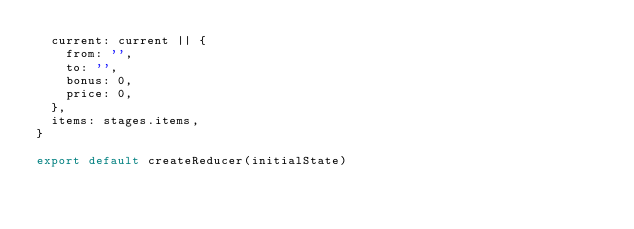Convert code to text. <code><loc_0><loc_0><loc_500><loc_500><_JavaScript_>  current: current || {
    from: '',
    to: '',
    bonus: 0,
    price: 0,
  },
  items: stages.items,
}

export default createReducer(initialState)
</code> 